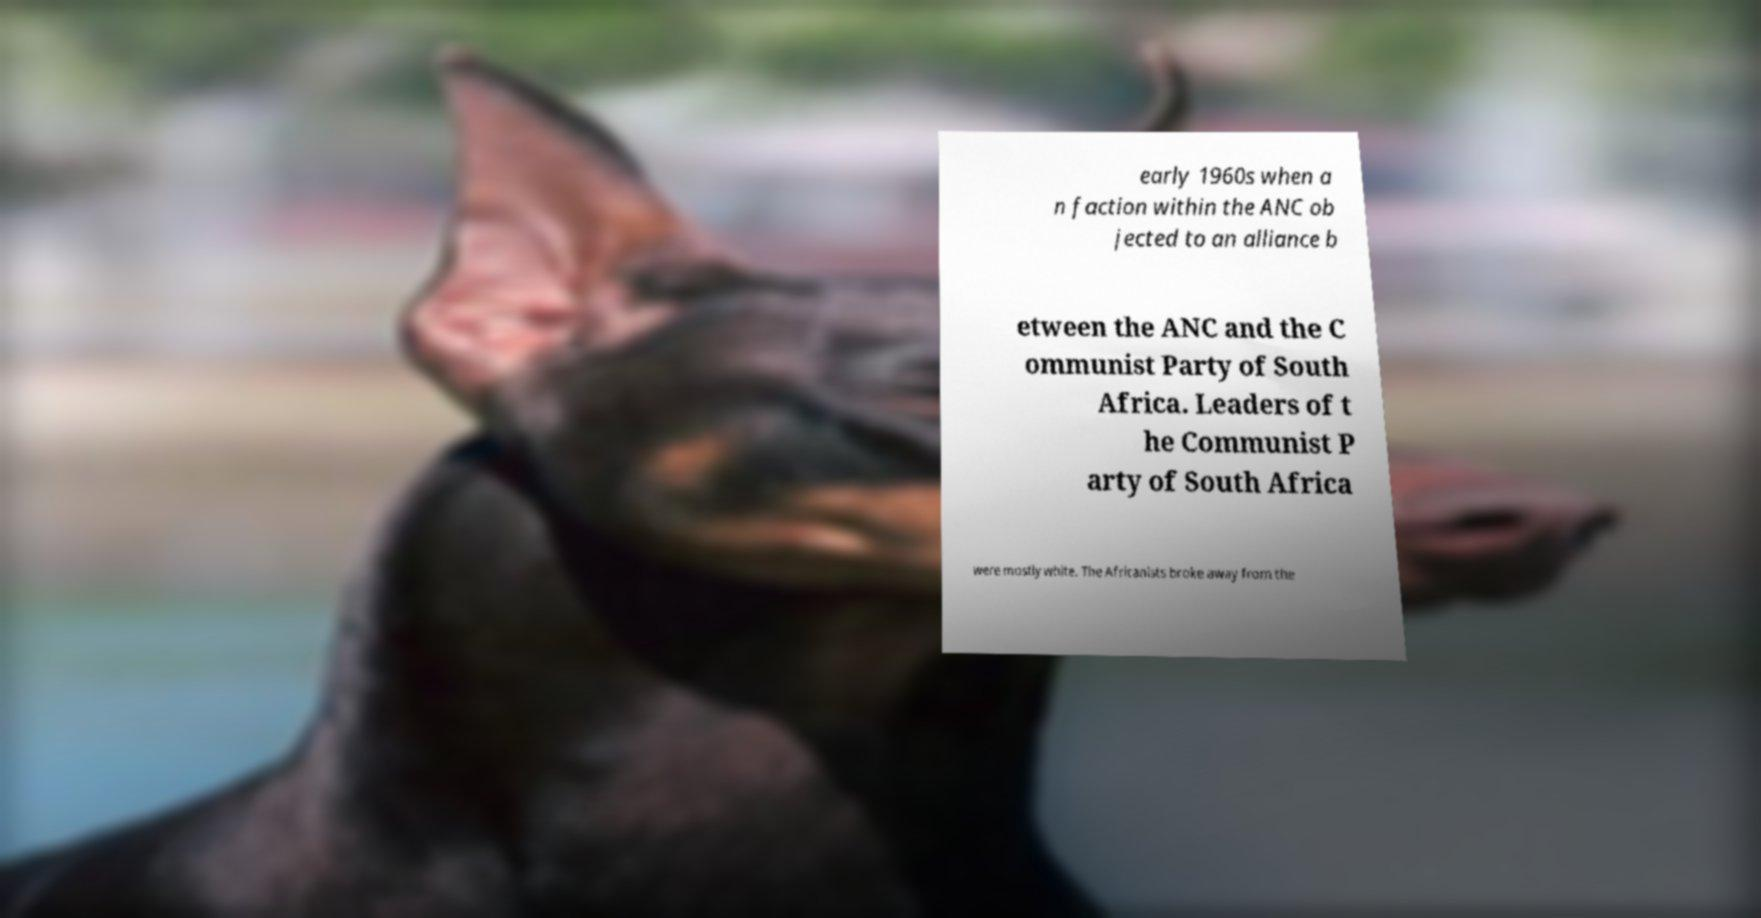I need the written content from this picture converted into text. Can you do that? early 1960s when a n faction within the ANC ob jected to an alliance b etween the ANC and the C ommunist Party of South Africa. Leaders of t he Communist P arty of South Africa were mostly white. The Africanists broke away from the 